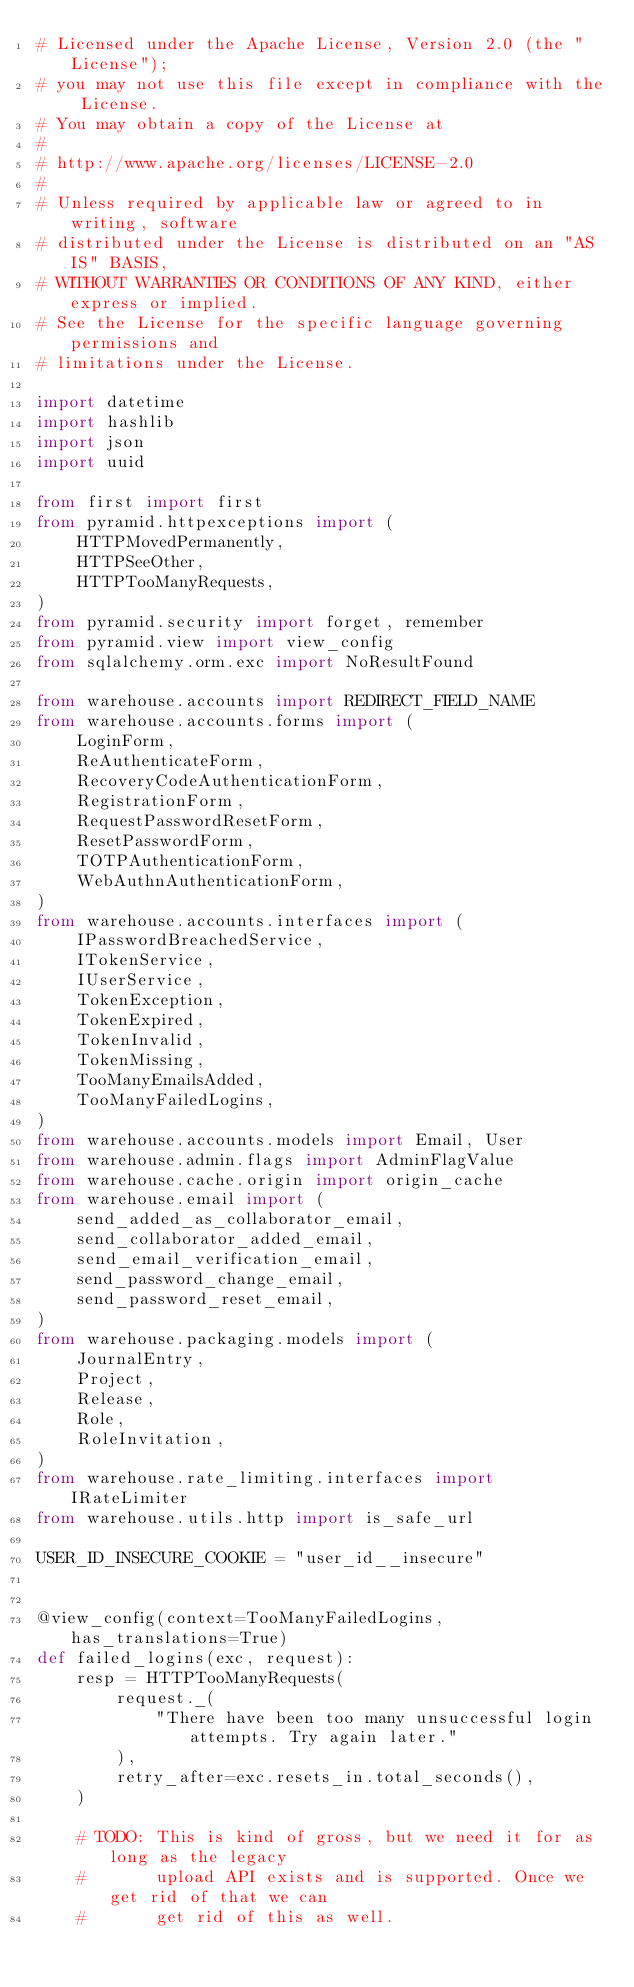Convert code to text. <code><loc_0><loc_0><loc_500><loc_500><_Python_># Licensed under the Apache License, Version 2.0 (the "License");
# you may not use this file except in compliance with the License.
# You may obtain a copy of the License at
#
# http://www.apache.org/licenses/LICENSE-2.0
#
# Unless required by applicable law or agreed to in writing, software
# distributed under the License is distributed on an "AS IS" BASIS,
# WITHOUT WARRANTIES OR CONDITIONS OF ANY KIND, either express or implied.
# See the License for the specific language governing permissions and
# limitations under the License.

import datetime
import hashlib
import json
import uuid

from first import first
from pyramid.httpexceptions import (
    HTTPMovedPermanently,
    HTTPSeeOther,
    HTTPTooManyRequests,
)
from pyramid.security import forget, remember
from pyramid.view import view_config
from sqlalchemy.orm.exc import NoResultFound

from warehouse.accounts import REDIRECT_FIELD_NAME
from warehouse.accounts.forms import (
    LoginForm,
    ReAuthenticateForm,
    RecoveryCodeAuthenticationForm,
    RegistrationForm,
    RequestPasswordResetForm,
    ResetPasswordForm,
    TOTPAuthenticationForm,
    WebAuthnAuthenticationForm,
)
from warehouse.accounts.interfaces import (
    IPasswordBreachedService,
    ITokenService,
    IUserService,
    TokenException,
    TokenExpired,
    TokenInvalid,
    TokenMissing,
    TooManyEmailsAdded,
    TooManyFailedLogins,
)
from warehouse.accounts.models import Email, User
from warehouse.admin.flags import AdminFlagValue
from warehouse.cache.origin import origin_cache
from warehouse.email import (
    send_added_as_collaborator_email,
    send_collaborator_added_email,
    send_email_verification_email,
    send_password_change_email,
    send_password_reset_email,
)
from warehouse.packaging.models import (
    JournalEntry,
    Project,
    Release,
    Role,
    RoleInvitation,
)
from warehouse.rate_limiting.interfaces import IRateLimiter
from warehouse.utils.http import is_safe_url

USER_ID_INSECURE_COOKIE = "user_id__insecure"


@view_config(context=TooManyFailedLogins, has_translations=True)
def failed_logins(exc, request):
    resp = HTTPTooManyRequests(
        request._(
            "There have been too many unsuccessful login attempts. Try again later."
        ),
        retry_after=exc.resets_in.total_seconds(),
    )

    # TODO: This is kind of gross, but we need it for as long as the legacy
    #       upload API exists and is supported. Once we get rid of that we can
    #       get rid of this as well.</code> 